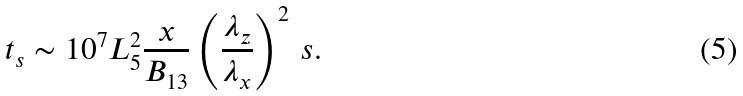Convert formula to latex. <formula><loc_0><loc_0><loc_500><loc_500>t _ { s } \sim 1 0 ^ { 7 } L _ { 5 } ^ { 2 } \frac { x } { B _ { 1 3 } } \left ( \frac { \lambda _ { z } } { \lambda _ { x } } \right ) ^ { 2 } \, s .</formula> 